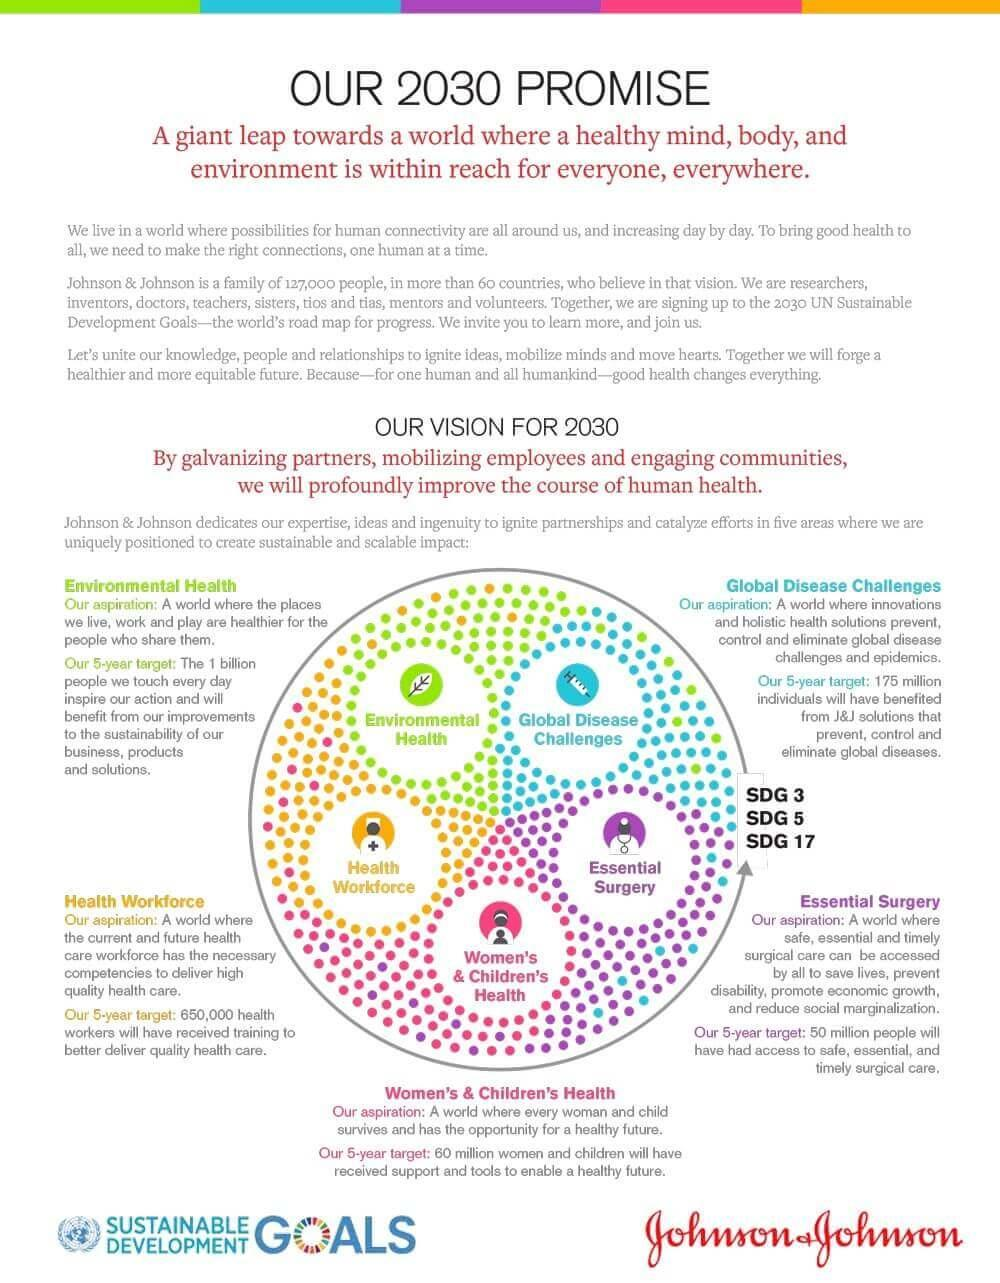What color represents "health workforce" in the infographic purple, blue or yellow?
Answer the question with a short phrase. yellow What color represents "environmental health" in the infographic purple, green or yellow? green What color represents "women's & Children's Health" in the infographic red, blue or yellow? red What color represents "essential surgery" in the infographic purple, blue or yellow? purple How many people will the solution to global disease challenges benefit in 5 years? 175 million How many people will the access to essential surgery benefit in 5 years? 50 million How many women and children will receive support to enable a healthy future in 5 years? 60 million What color represents "global disease challenges" in the infographic purple, blue or yellow? blue 